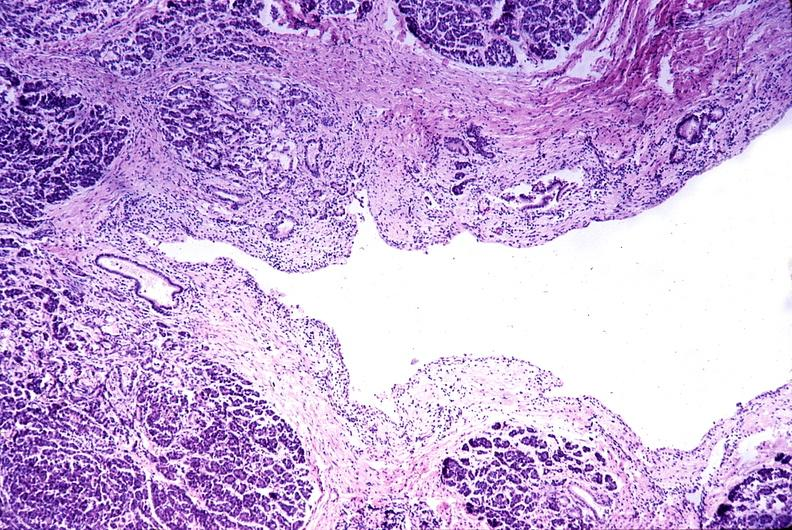what does this image show?
Answer the question using a single word or phrase. Chronic pancreatitis 